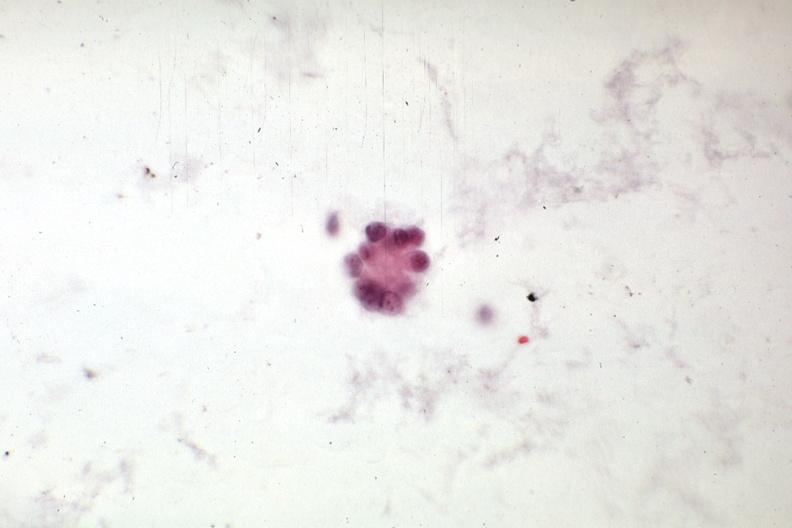s abdomen present?
Answer the question using a single word or phrase. Yes 